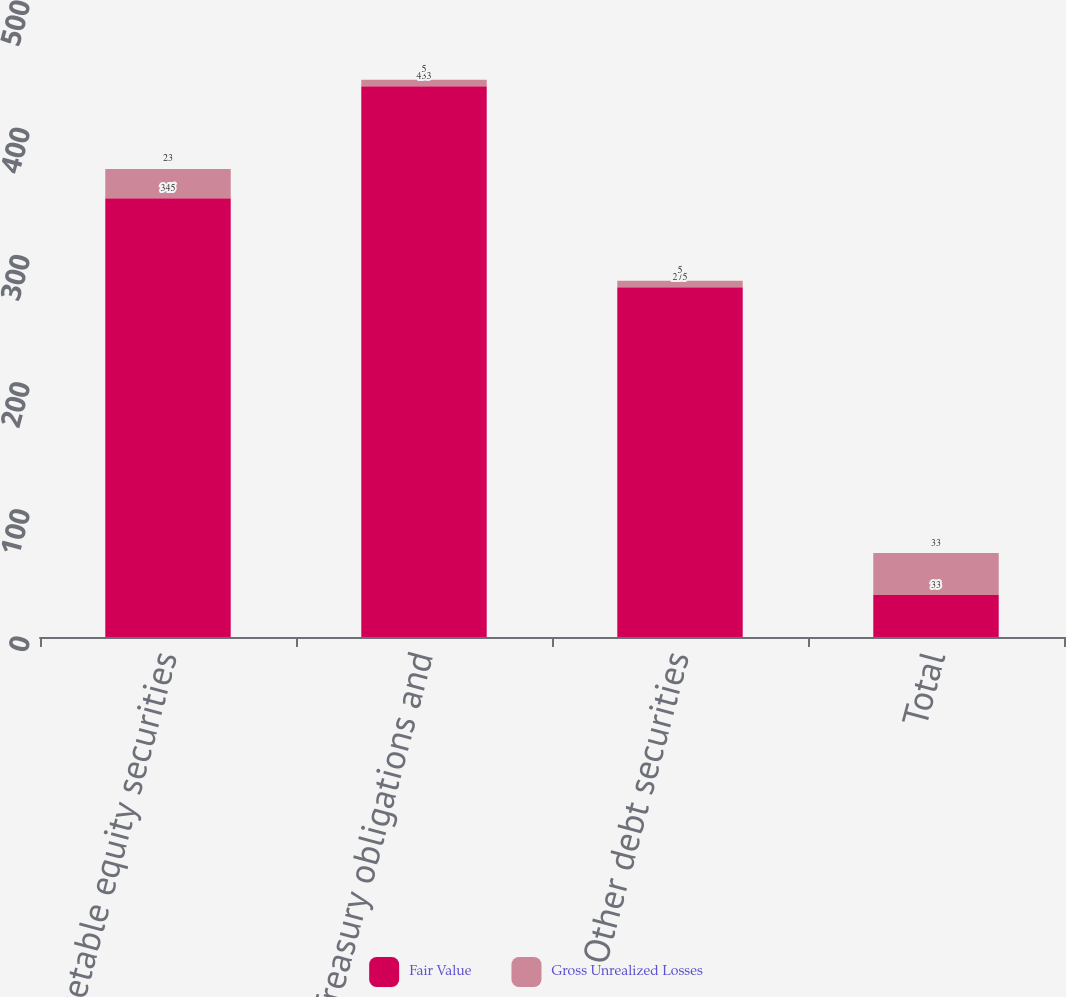Convert chart. <chart><loc_0><loc_0><loc_500><loc_500><stacked_bar_chart><ecel><fcel>Marketable equity securities<fcel>US Treasury obligations and<fcel>Other debt securities<fcel>Total<nl><fcel>Fair Value<fcel>345<fcel>433<fcel>275<fcel>33<nl><fcel>Gross Unrealized Losses<fcel>23<fcel>5<fcel>5<fcel>33<nl></chart> 